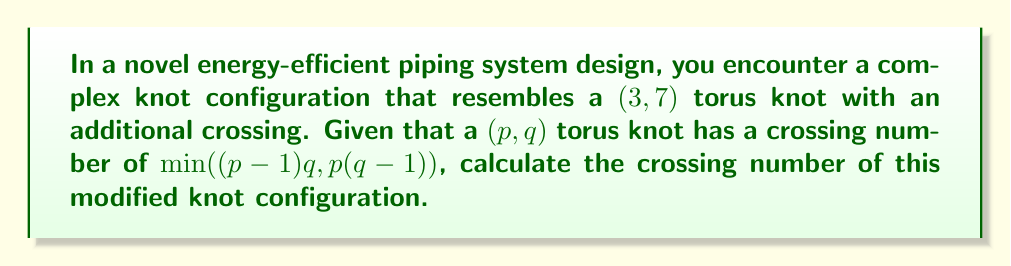Show me your answer to this math problem. Let's approach this step-by-step:

1) First, recall the formula for the crossing number of a $(p,q)$ torus knot:
   $$c(T_{p,q}) = \min((p-1)q, p(q-1))$$

2) In our case, we have a $(3,7)$ torus knot. Let's calculate its crossing number:
   $$c(T_{3,7}) = \min((3-1)7, 3(7-1))$$
   $$c(T_{3,7}) = \min(14, 18) = 14$$

3) The standard $(3,7)$ torus knot has 14 crossings.

4) However, the question states that there is an additional crossing in this modified configuration.

5) To account for this extra crossing, we simply add 1 to the crossing number of the standard $(3,7)$ torus knot:
   $$c(\text{modified knot}) = c(T_{3,7}) + 1 = 14 + 1 = 15$$

Therefore, the crossing number of the modified knot configuration is 15.
Answer: 15 